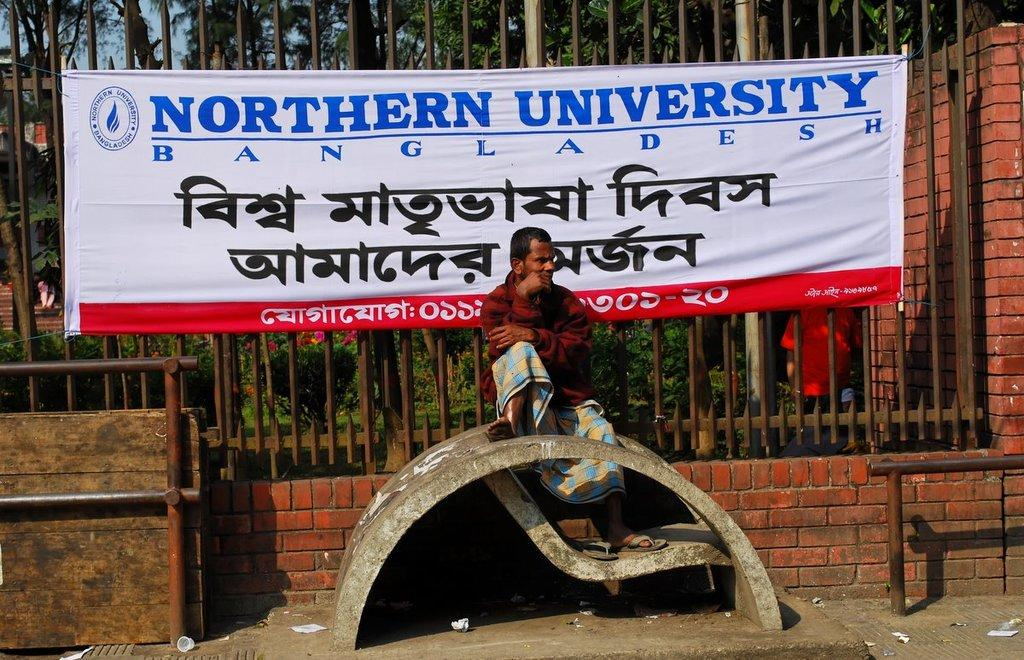What is the man in the image doing? The man is sitting on a bench in the image. What is located behind the man? There is a fencing behind the man. What is attached to the fencing? There is a banner on the fencing. What can be seen beyond the fencing? Trees and plants are visible behind the fencing. What type of soup is being served at the game in the image? There is no soup or game present in the image; it features a man sitting on a bench with a fencing and banner in the background. 